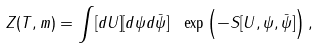Convert formula to latex. <formula><loc_0><loc_0><loc_500><loc_500>Z ( T , m ) = \int [ d U ] [ d \psi d \bar { \psi } ] \ \exp \left ( - S [ U , \psi , \bar { \psi } ] \right ) ,</formula> 